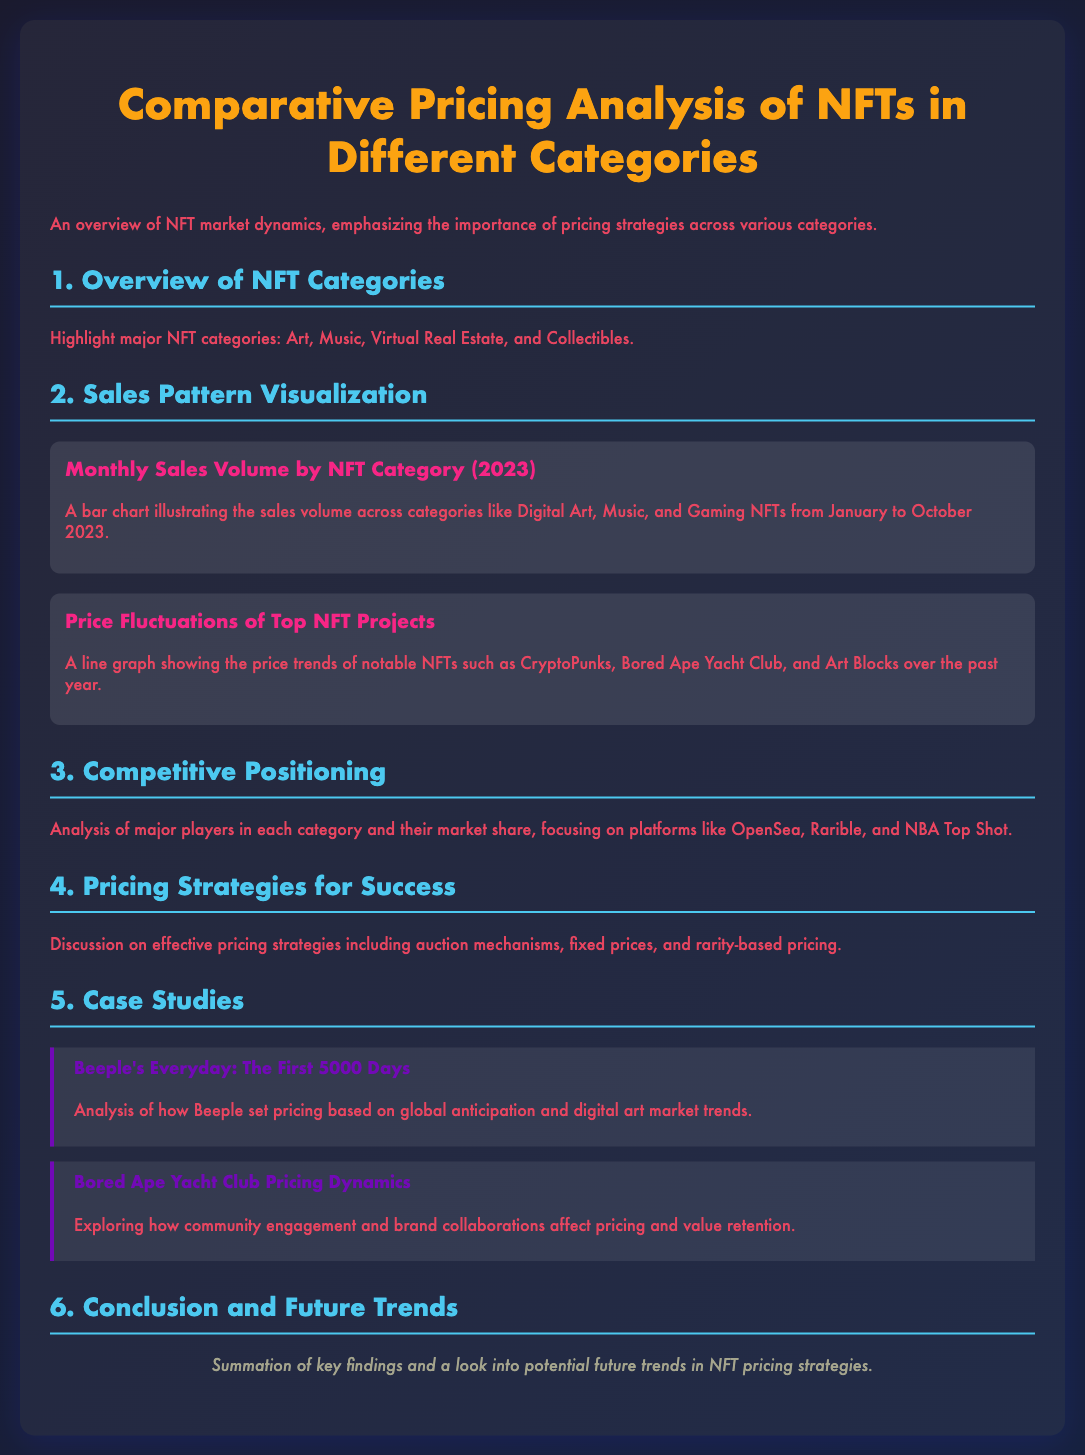what are the major NFT categories highlighted? The document mentions major NFT categories including Art, Music, Virtual Real Estate, and Collectibles.
Answer: Art, Music, Virtual Real Estate, Collectibles what does the bar chart illustrate? The bar chart in the document illustrates the sales volume across categories like Digital Art, Music, and Gaming NFTs from January to October 2023.
Answer: Sales volume across categories who are the major players analyzed in the competitive positioning section? The document focuses on major players like OpenSea, Rarible, and NBA Top Shot in the competitive positioning section.
Answer: OpenSea, Rarible, NBA Top Shot what analysis is discussed regarding Beeple's Everyday? The analysis discusses how Beeple set pricing based on global anticipation and digital art market trends.
Answer: Global anticipation and digital art market trends what is the main topic of the conclusion section? The conclusion section summarizes key findings and looks into potential future trends in NFT pricing strategies.
Answer: Key findings and future trends 